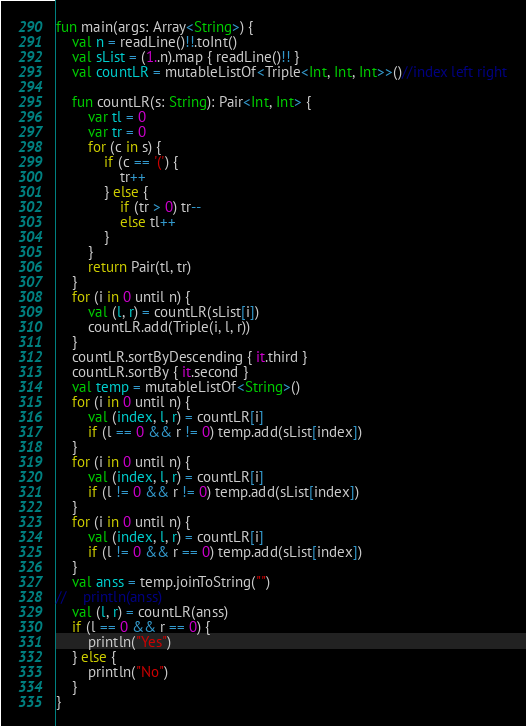Convert code to text. <code><loc_0><loc_0><loc_500><loc_500><_Kotlin_>fun main(args: Array<String>) {
    val n = readLine()!!.toInt()
    val sList = (1..n).map { readLine()!! }
    val countLR = mutableListOf<Triple<Int, Int, Int>>()//index left right

    fun countLR(s: String): Pair<Int, Int> {
        var tl = 0
        var tr = 0
        for (c in s) {
            if (c == '(') {
                tr++
            } else {
                if (tr > 0) tr--
                else tl++
            }
        }
        return Pair(tl, tr)
    }
    for (i in 0 until n) {
        val (l, r) = countLR(sList[i])
        countLR.add(Triple(i, l, r))
    }
    countLR.sortByDescending { it.third }
    countLR.sortBy { it.second }
    val temp = mutableListOf<String>()
    for (i in 0 until n) {
        val (index, l, r) = countLR[i]
        if (l == 0 && r != 0) temp.add(sList[index])
    }
    for (i in 0 until n) {
        val (index, l, r) = countLR[i]
        if (l != 0 && r != 0) temp.add(sList[index])
    }
    for (i in 0 until n) {
        val (index, l, r) = countLR[i]
        if (l != 0 && r == 0) temp.add(sList[index])
    }
    val anss = temp.joinToString("")
//    println(anss)
    val (l, r) = countLR(anss)
    if (l == 0 && r == 0) {
        println("Yes")
    } else {
        println("No")
    }
}
</code> 